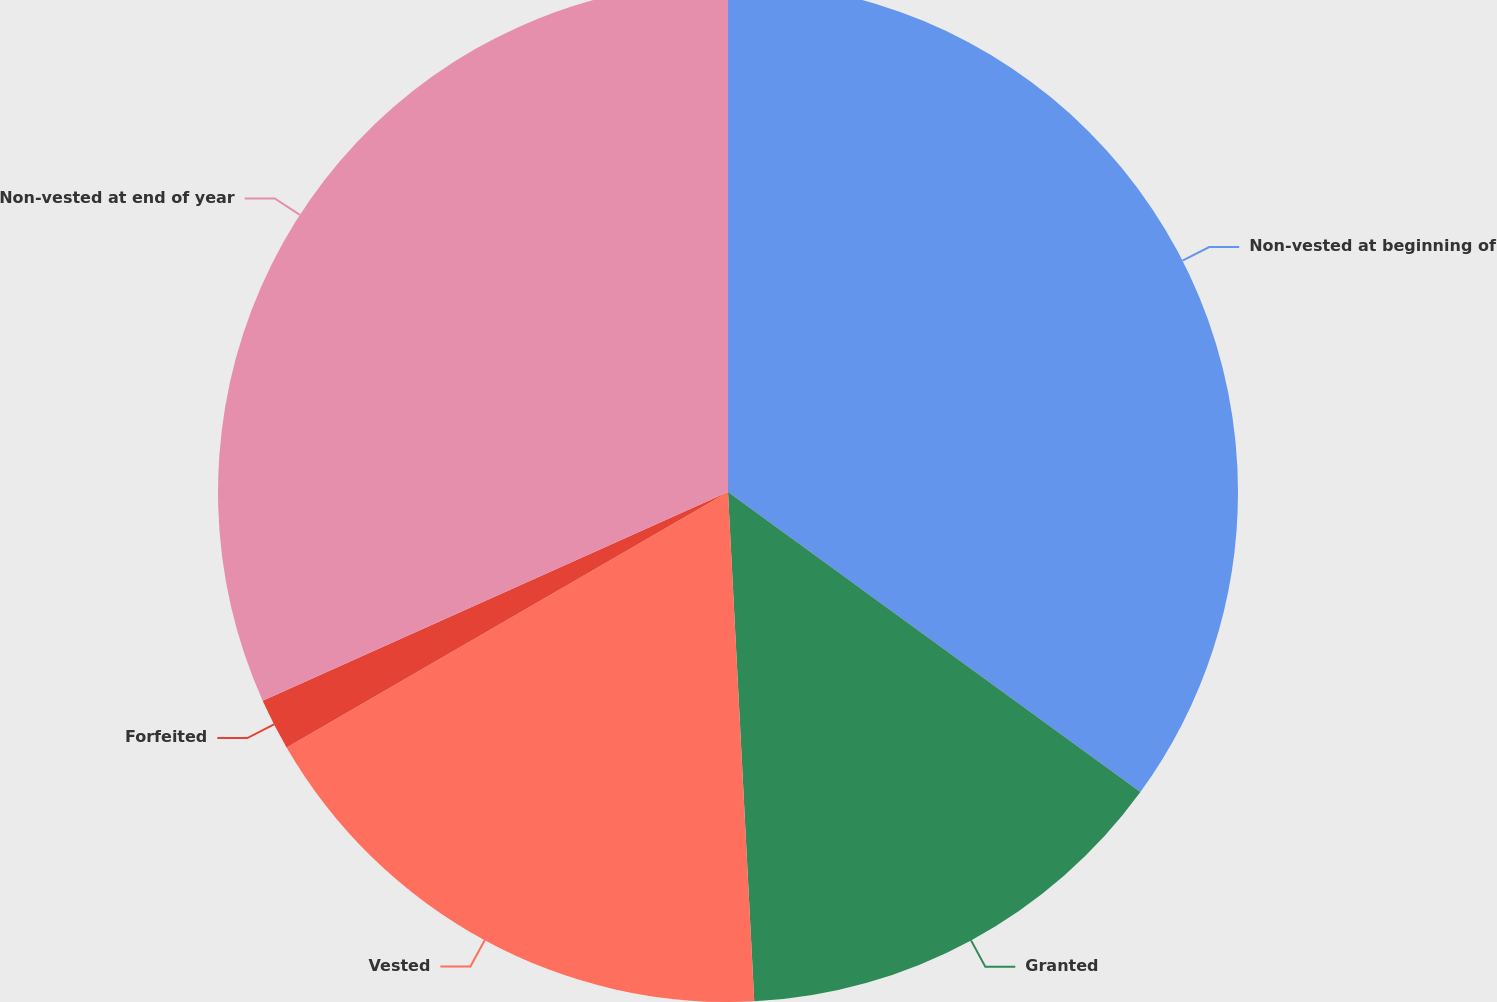<chart> <loc_0><loc_0><loc_500><loc_500><pie_chart><fcel>Non-vested at beginning of<fcel>Granted<fcel>Vested<fcel>Forfeited<fcel>Non-vested at end of year<nl><fcel>35.01%<fcel>14.17%<fcel>17.47%<fcel>1.64%<fcel>31.71%<nl></chart> 